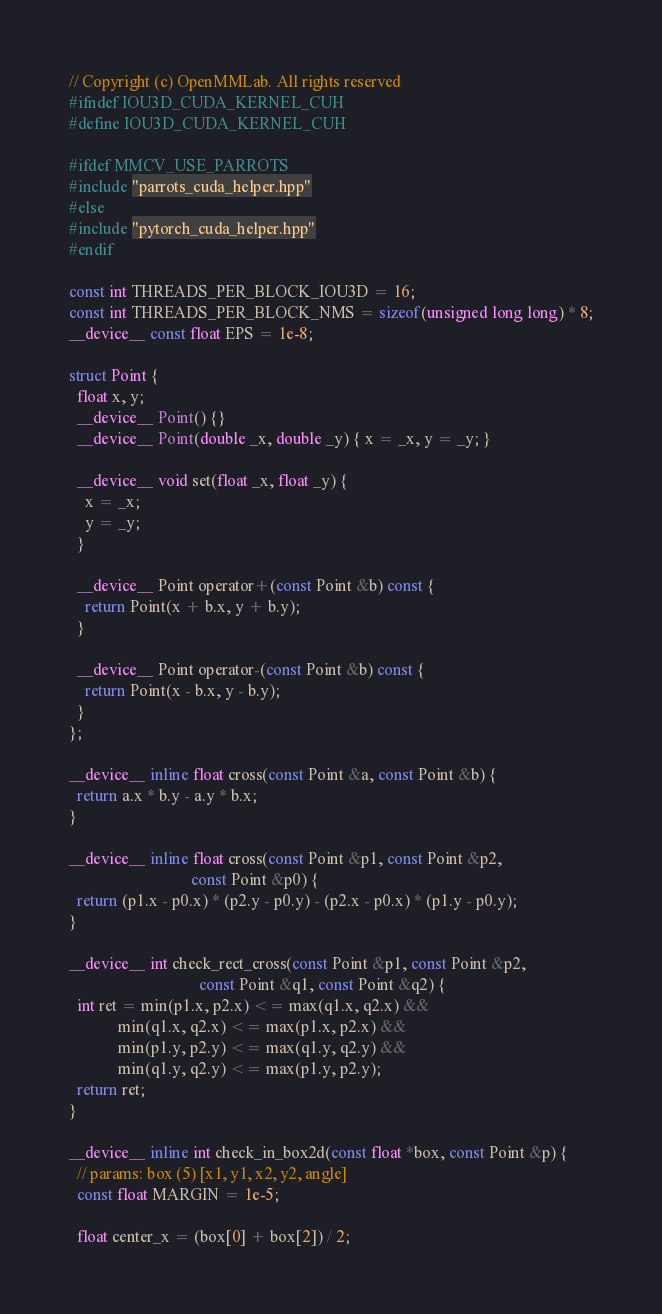<code> <loc_0><loc_0><loc_500><loc_500><_Cuda_>// Copyright (c) OpenMMLab. All rights reserved
#ifndef IOU3D_CUDA_KERNEL_CUH
#define IOU3D_CUDA_KERNEL_CUH

#ifdef MMCV_USE_PARROTS
#include "parrots_cuda_helper.hpp"
#else
#include "pytorch_cuda_helper.hpp"
#endif

const int THREADS_PER_BLOCK_IOU3D = 16;
const int THREADS_PER_BLOCK_NMS = sizeof(unsigned long long) * 8;
__device__ const float EPS = 1e-8;

struct Point {
  float x, y;
  __device__ Point() {}
  __device__ Point(double _x, double _y) { x = _x, y = _y; }

  __device__ void set(float _x, float _y) {
    x = _x;
    y = _y;
  }

  __device__ Point operator+(const Point &b) const {
    return Point(x + b.x, y + b.y);
  }

  __device__ Point operator-(const Point &b) const {
    return Point(x - b.x, y - b.y);
  }
};

__device__ inline float cross(const Point &a, const Point &b) {
  return a.x * b.y - a.y * b.x;
}

__device__ inline float cross(const Point &p1, const Point &p2,
                              const Point &p0) {
  return (p1.x - p0.x) * (p2.y - p0.y) - (p2.x - p0.x) * (p1.y - p0.y);
}

__device__ int check_rect_cross(const Point &p1, const Point &p2,
                                const Point &q1, const Point &q2) {
  int ret = min(p1.x, p2.x) <= max(q1.x, q2.x) &&
            min(q1.x, q2.x) <= max(p1.x, p2.x) &&
            min(p1.y, p2.y) <= max(q1.y, q2.y) &&
            min(q1.y, q2.y) <= max(p1.y, p2.y);
  return ret;
}

__device__ inline int check_in_box2d(const float *box, const Point &p) {
  // params: box (5) [x1, y1, x2, y2, angle]
  const float MARGIN = 1e-5;

  float center_x = (box[0] + box[2]) / 2;</code> 